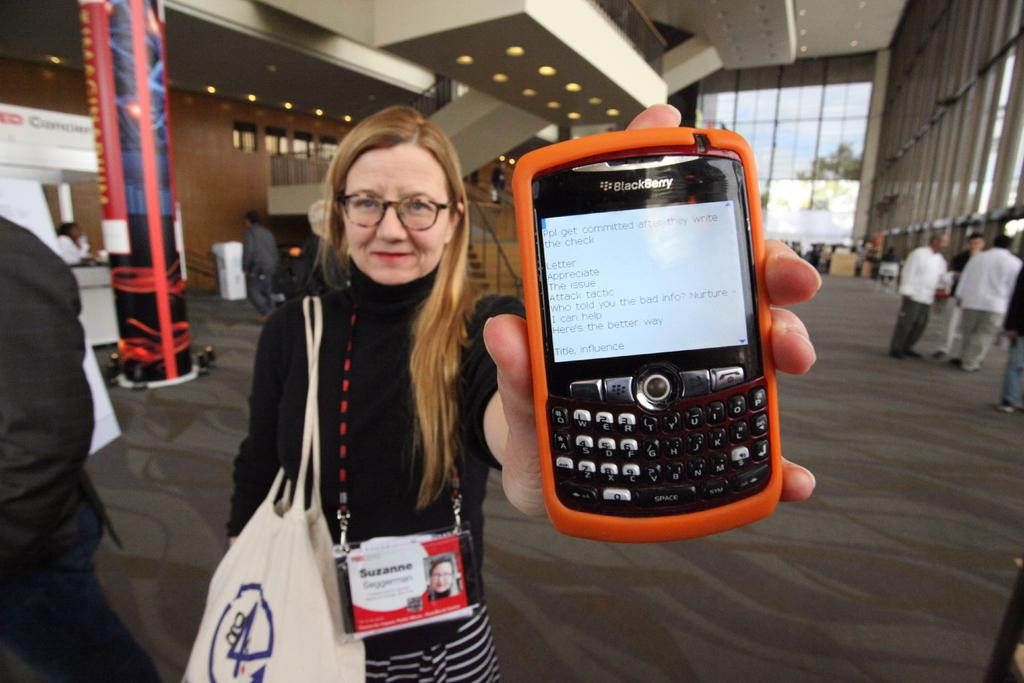<image>
Create a compact narrative representing the image presented. A woman holding a Blackberry with an orange case on it 